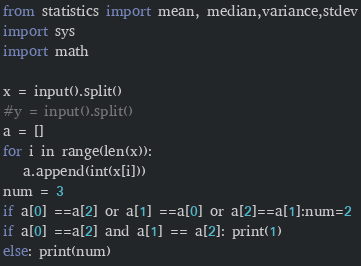Convert code to text. <code><loc_0><loc_0><loc_500><loc_500><_Python_>from statistics import mean, median,variance,stdev
import sys
import math

x = input().split()
#y = input().split()
a = []
for i in range(len(x)):
   a.append(int(x[i]))
num = 3
if a[0] ==a[2] or a[1] ==a[0] or a[2]==a[1]:num=2
if a[0] ==a[2] and a[1] == a[2]: print(1)
else: print(num)
</code> 